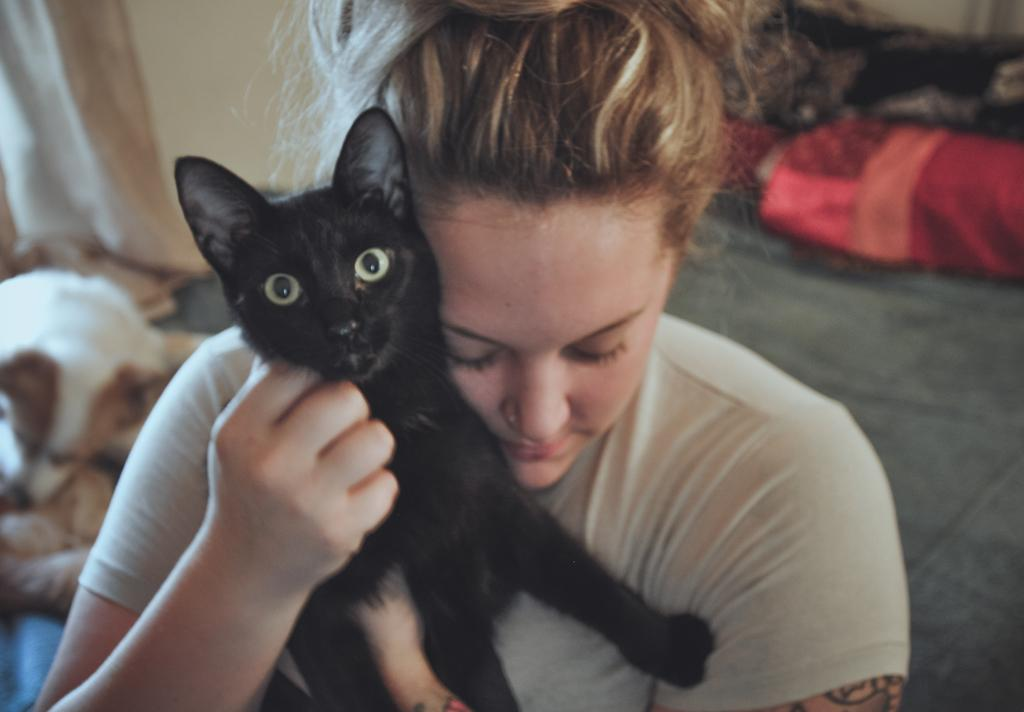Who is the main subject in the image? There is a woman in the center of the image. What is the woman holding in the image? The woman is holding a cat. What other animal can be seen in the image? There is a dog in the background of the image. What is visible in the background of the image? There is a curtain in the background of the image. Can you describe the object on the right side of the image? There is an object on the right side of the image that is red in color. Is the woman in the image trying to pull the tooth out of the dog's mouth? There is no tooth or dog's mouth visible in the image, so it is not possible to determine if the woman is trying to pull a tooth out. 